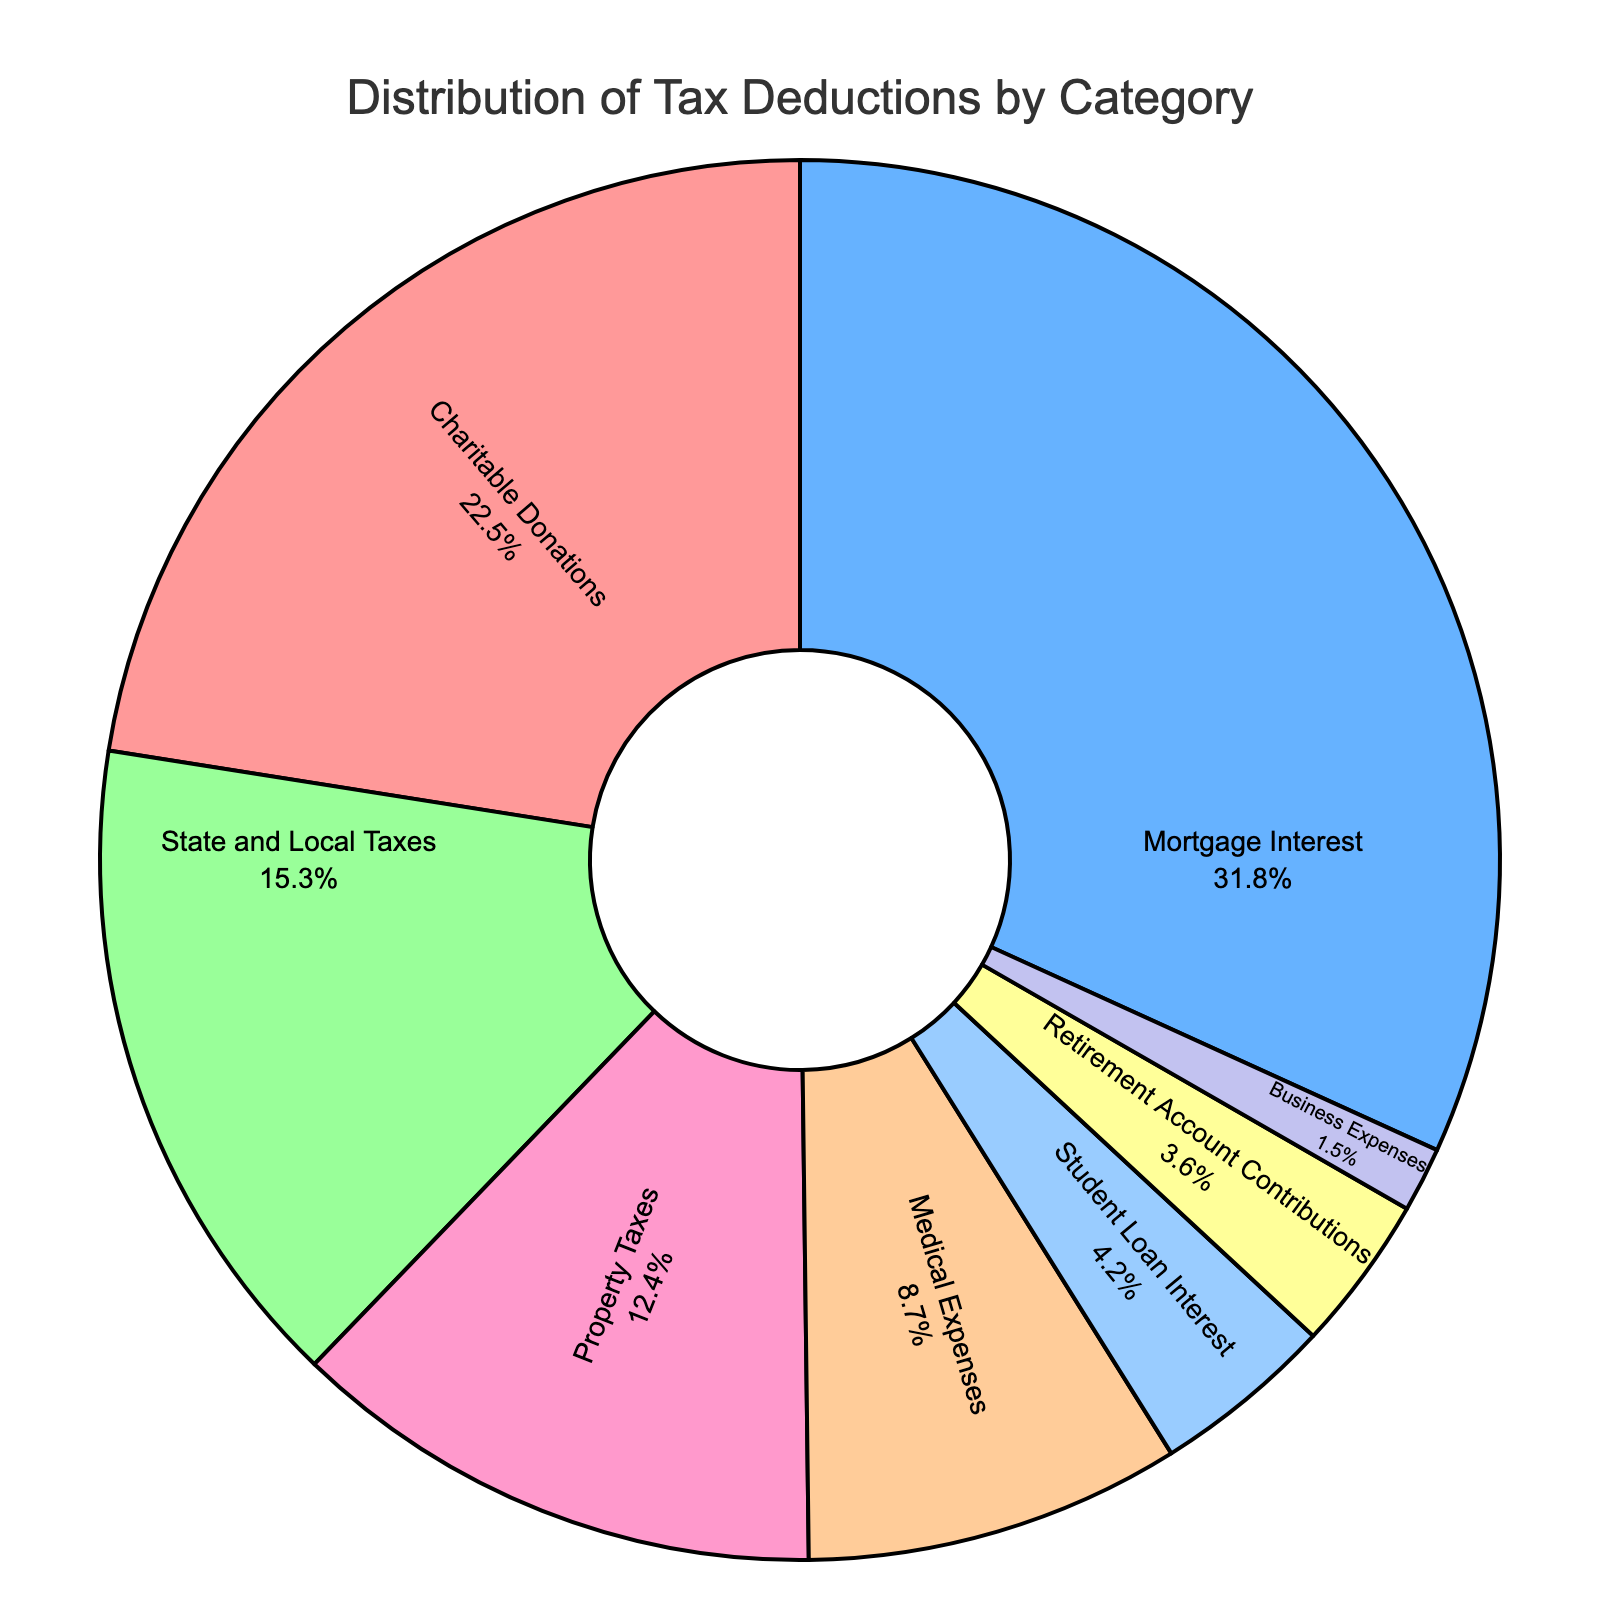What percentage of tax deductions is claimed from mortgage interest? Look at the pie chart and find the section labeled "Mortgage Interest." The percentage associated with it is 31.8%.
Answer: 31.8% Which category has the smallest share of tax deductions? Identify the slice with the smallest percentage. "Business Expenses" has the smallest percentage at 1.5%.
Answer: Business Expenses How much higher is the percentage of mortgage interest deductions compared to the percentage of charitable donations deductions? Mortgage Interest is 31.8% and Charitable Donations are 22.5%. Subtract 22.5 from 31.8 to get the difference: 31.8 - 22.5 = 9.3.
Answer: 9.3% What is the combined percentage of deductions for State and Local Taxes and Property Taxes? Add the percentages for State and Local Taxes (15.3%) and Property Taxes (12.4%). 15.3 + 12.4 = 27.7.
Answer: 27.7% Are contributions to retirement accounts more or less common than student loan interest deductions? Compare the percentages for Retirement Account Contributions (3.6%) and Student Loan Interest (4.2%). Retirement Account Contributions are less than Student Loan Interest.
Answer: Less What's the sum of all categories that have a percentage less than 10%? Identify categories with less than 10%: Medical Expenses (8.7%), Student Loan Interest (4.2%), Retirement Account Contributions (3.6%), Business Expenses (1.5%). Add these percentages: 8.7 + 4.2 + 3.6 + 1.5 = 18.0.
Answer: 18.0% How many categories have a percentage greater than 10%? Identify the slices of the pie chart with percentages greater than 10%: Charitable Donations, Mortgage Interest, State and Local Taxes, Property Taxes. There are 4 such categories.
Answer: 4 Which category has a higher percentage, Medical Expenses or Property Taxes? Compare the percentages for Medical Expenses (8.7%) and Property Taxes (12.4%). Property Taxes have a higher percentage.
Answer: Property Taxes What is the average percentage of the three least common deduction categories? The three least common categories are Business Expenses (1.5%), Retirement Account Contributions (3.6%), Student Loan Interest (4.2%). Calculate the average by summing these percentages and dividing by 3: (1.5 + 3.6 + 4.2) / 3 = 9.3 / 3 = 3.1.
Answer: 3.1% What is the visual relationship between the colors used for Medical Expenses and Business Expenses in the pie chart? Observe the colors associated with Medical Expenses and Business Expenses. Medical Expenses are represented by a peach color, while Business Expenses are a light purple. Note these are distinct colors and easily distinguishable.
Answer: Distinct and easily distinguishable 